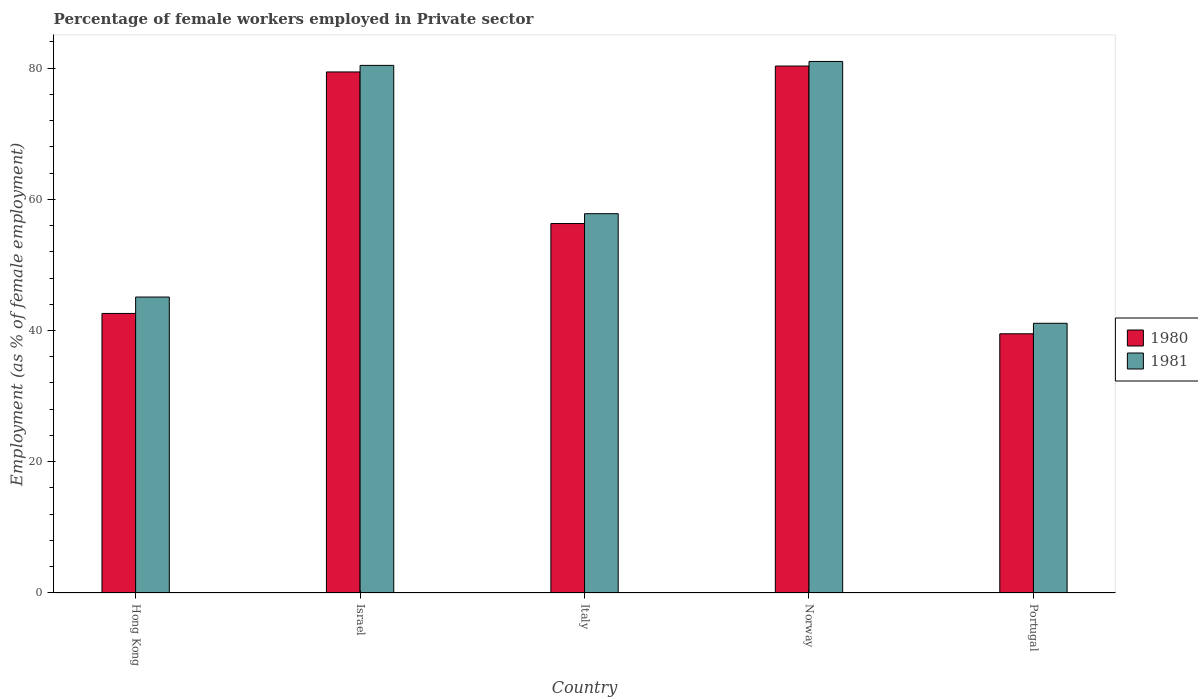How many different coloured bars are there?
Ensure brevity in your answer.  2. How many groups of bars are there?
Keep it short and to the point. 5. How many bars are there on the 1st tick from the left?
Offer a very short reply. 2. What is the label of the 5th group of bars from the left?
Your response must be concise. Portugal. In how many cases, is the number of bars for a given country not equal to the number of legend labels?
Provide a succinct answer. 0. What is the percentage of females employed in Private sector in 1981 in Israel?
Provide a short and direct response. 80.4. Across all countries, what is the maximum percentage of females employed in Private sector in 1980?
Give a very brief answer. 80.3. Across all countries, what is the minimum percentage of females employed in Private sector in 1981?
Your answer should be very brief. 41.1. In which country was the percentage of females employed in Private sector in 1980 minimum?
Make the answer very short. Portugal. What is the total percentage of females employed in Private sector in 1981 in the graph?
Offer a very short reply. 305.4. What is the difference between the percentage of females employed in Private sector in 1980 in Israel and that in Italy?
Give a very brief answer. 23.1. What is the difference between the percentage of females employed in Private sector in 1980 in Norway and the percentage of females employed in Private sector in 1981 in Italy?
Your answer should be compact. 22.5. What is the average percentage of females employed in Private sector in 1980 per country?
Offer a very short reply. 59.62. What is the difference between the percentage of females employed in Private sector of/in 1981 and percentage of females employed in Private sector of/in 1980 in Portugal?
Your answer should be compact. 1.6. What is the ratio of the percentage of females employed in Private sector in 1980 in Norway to that in Portugal?
Provide a short and direct response. 2.03. Is the percentage of females employed in Private sector in 1980 in Hong Kong less than that in Italy?
Give a very brief answer. Yes. Is the difference between the percentage of females employed in Private sector in 1981 in Israel and Portugal greater than the difference between the percentage of females employed in Private sector in 1980 in Israel and Portugal?
Provide a short and direct response. No. What is the difference between the highest and the second highest percentage of females employed in Private sector in 1981?
Offer a terse response. -0.6. What is the difference between the highest and the lowest percentage of females employed in Private sector in 1980?
Offer a terse response. 40.8. In how many countries, is the percentage of females employed in Private sector in 1981 greater than the average percentage of females employed in Private sector in 1981 taken over all countries?
Your answer should be very brief. 2. What does the 1st bar from the left in Israel represents?
Your answer should be very brief. 1980. How many bars are there?
Your answer should be compact. 10. How many countries are there in the graph?
Offer a terse response. 5. What is the difference between two consecutive major ticks on the Y-axis?
Ensure brevity in your answer.  20. Are the values on the major ticks of Y-axis written in scientific E-notation?
Keep it short and to the point. No. Does the graph contain any zero values?
Provide a succinct answer. No. Does the graph contain grids?
Provide a short and direct response. No. Where does the legend appear in the graph?
Your response must be concise. Center right. How many legend labels are there?
Offer a very short reply. 2. What is the title of the graph?
Keep it short and to the point. Percentage of female workers employed in Private sector. What is the label or title of the Y-axis?
Offer a very short reply. Employment (as % of female employment). What is the Employment (as % of female employment) of 1980 in Hong Kong?
Ensure brevity in your answer.  42.6. What is the Employment (as % of female employment) in 1981 in Hong Kong?
Provide a short and direct response. 45.1. What is the Employment (as % of female employment) in 1980 in Israel?
Keep it short and to the point. 79.4. What is the Employment (as % of female employment) in 1981 in Israel?
Give a very brief answer. 80.4. What is the Employment (as % of female employment) of 1980 in Italy?
Give a very brief answer. 56.3. What is the Employment (as % of female employment) in 1981 in Italy?
Offer a very short reply. 57.8. What is the Employment (as % of female employment) of 1980 in Norway?
Your answer should be very brief. 80.3. What is the Employment (as % of female employment) of 1980 in Portugal?
Ensure brevity in your answer.  39.5. What is the Employment (as % of female employment) in 1981 in Portugal?
Offer a terse response. 41.1. Across all countries, what is the maximum Employment (as % of female employment) in 1980?
Make the answer very short. 80.3. Across all countries, what is the minimum Employment (as % of female employment) of 1980?
Provide a short and direct response. 39.5. Across all countries, what is the minimum Employment (as % of female employment) of 1981?
Make the answer very short. 41.1. What is the total Employment (as % of female employment) in 1980 in the graph?
Ensure brevity in your answer.  298.1. What is the total Employment (as % of female employment) in 1981 in the graph?
Ensure brevity in your answer.  305.4. What is the difference between the Employment (as % of female employment) of 1980 in Hong Kong and that in Israel?
Keep it short and to the point. -36.8. What is the difference between the Employment (as % of female employment) of 1981 in Hong Kong and that in Israel?
Provide a succinct answer. -35.3. What is the difference between the Employment (as % of female employment) of 1980 in Hong Kong and that in Italy?
Provide a succinct answer. -13.7. What is the difference between the Employment (as % of female employment) of 1981 in Hong Kong and that in Italy?
Ensure brevity in your answer.  -12.7. What is the difference between the Employment (as % of female employment) in 1980 in Hong Kong and that in Norway?
Provide a succinct answer. -37.7. What is the difference between the Employment (as % of female employment) of 1981 in Hong Kong and that in Norway?
Offer a terse response. -35.9. What is the difference between the Employment (as % of female employment) of 1980 in Hong Kong and that in Portugal?
Your answer should be compact. 3.1. What is the difference between the Employment (as % of female employment) of 1980 in Israel and that in Italy?
Offer a terse response. 23.1. What is the difference between the Employment (as % of female employment) in 1981 in Israel and that in Italy?
Your answer should be compact. 22.6. What is the difference between the Employment (as % of female employment) of 1980 in Israel and that in Portugal?
Ensure brevity in your answer.  39.9. What is the difference between the Employment (as % of female employment) of 1981 in Israel and that in Portugal?
Your answer should be compact. 39.3. What is the difference between the Employment (as % of female employment) in 1981 in Italy and that in Norway?
Your answer should be compact. -23.2. What is the difference between the Employment (as % of female employment) of 1980 in Italy and that in Portugal?
Your answer should be compact. 16.8. What is the difference between the Employment (as % of female employment) of 1980 in Norway and that in Portugal?
Offer a very short reply. 40.8. What is the difference between the Employment (as % of female employment) in 1981 in Norway and that in Portugal?
Your answer should be very brief. 39.9. What is the difference between the Employment (as % of female employment) in 1980 in Hong Kong and the Employment (as % of female employment) in 1981 in Israel?
Make the answer very short. -37.8. What is the difference between the Employment (as % of female employment) in 1980 in Hong Kong and the Employment (as % of female employment) in 1981 in Italy?
Offer a terse response. -15.2. What is the difference between the Employment (as % of female employment) of 1980 in Hong Kong and the Employment (as % of female employment) of 1981 in Norway?
Provide a succinct answer. -38.4. What is the difference between the Employment (as % of female employment) in 1980 in Hong Kong and the Employment (as % of female employment) in 1981 in Portugal?
Your response must be concise. 1.5. What is the difference between the Employment (as % of female employment) in 1980 in Israel and the Employment (as % of female employment) in 1981 in Italy?
Your response must be concise. 21.6. What is the difference between the Employment (as % of female employment) in 1980 in Israel and the Employment (as % of female employment) in 1981 in Norway?
Keep it short and to the point. -1.6. What is the difference between the Employment (as % of female employment) in 1980 in Israel and the Employment (as % of female employment) in 1981 in Portugal?
Offer a terse response. 38.3. What is the difference between the Employment (as % of female employment) of 1980 in Italy and the Employment (as % of female employment) of 1981 in Norway?
Your response must be concise. -24.7. What is the difference between the Employment (as % of female employment) in 1980 in Italy and the Employment (as % of female employment) in 1981 in Portugal?
Provide a short and direct response. 15.2. What is the difference between the Employment (as % of female employment) of 1980 in Norway and the Employment (as % of female employment) of 1981 in Portugal?
Your answer should be compact. 39.2. What is the average Employment (as % of female employment) of 1980 per country?
Ensure brevity in your answer.  59.62. What is the average Employment (as % of female employment) in 1981 per country?
Ensure brevity in your answer.  61.08. What is the difference between the Employment (as % of female employment) in 1980 and Employment (as % of female employment) in 1981 in Israel?
Your answer should be compact. -1. What is the difference between the Employment (as % of female employment) of 1980 and Employment (as % of female employment) of 1981 in Italy?
Your answer should be very brief. -1.5. What is the difference between the Employment (as % of female employment) of 1980 and Employment (as % of female employment) of 1981 in Portugal?
Give a very brief answer. -1.6. What is the ratio of the Employment (as % of female employment) of 1980 in Hong Kong to that in Israel?
Keep it short and to the point. 0.54. What is the ratio of the Employment (as % of female employment) in 1981 in Hong Kong to that in Israel?
Keep it short and to the point. 0.56. What is the ratio of the Employment (as % of female employment) in 1980 in Hong Kong to that in Italy?
Offer a very short reply. 0.76. What is the ratio of the Employment (as % of female employment) in 1981 in Hong Kong to that in Italy?
Offer a very short reply. 0.78. What is the ratio of the Employment (as % of female employment) of 1980 in Hong Kong to that in Norway?
Offer a terse response. 0.53. What is the ratio of the Employment (as % of female employment) in 1981 in Hong Kong to that in Norway?
Your response must be concise. 0.56. What is the ratio of the Employment (as % of female employment) in 1980 in Hong Kong to that in Portugal?
Offer a terse response. 1.08. What is the ratio of the Employment (as % of female employment) in 1981 in Hong Kong to that in Portugal?
Provide a succinct answer. 1.1. What is the ratio of the Employment (as % of female employment) of 1980 in Israel to that in Italy?
Offer a terse response. 1.41. What is the ratio of the Employment (as % of female employment) in 1981 in Israel to that in Italy?
Provide a short and direct response. 1.39. What is the ratio of the Employment (as % of female employment) in 1980 in Israel to that in Portugal?
Keep it short and to the point. 2.01. What is the ratio of the Employment (as % of female employment) in 1981 in Israel to that in Portugal?
Provide a succinct answer. 1.96. What is the ratio of the Employment (as % of female employment) in 1980 in Italy to that in Norway?
Keep it short and to the point. 0.7. What is the ratio of the Employment (as % of female employment) in 1981 in Italy to that in Norway?
Provide a short and direct response. 0.71. What is the ratio of the Employment (as % of female employment) in 1980 in Italy to that in Portugal?
Your answer should be compact. 1.43. What is the ratio of the Employment (as % of female employment) of 1981 in Italy to that in Portugal?
Give a very brief answer. 1.41. What is the ratio of the Employment (as % of female employment) in 1980 in Norway to that in Portugal?
Your answer should be compact. 2.03. What is the ratio of the Employment (as % of female employment) in 1981 in Norway to that in Portugal?
Offer a terse response. 1.97. What is the difference between the highest and the lowest Employment (as % of female employment) of 1980?
Your response must be concise. 40.8. What is the difference between the highest and the lowest Employment (as % of female employment) in 1981?
Your answer should be very brief. 39.9. 